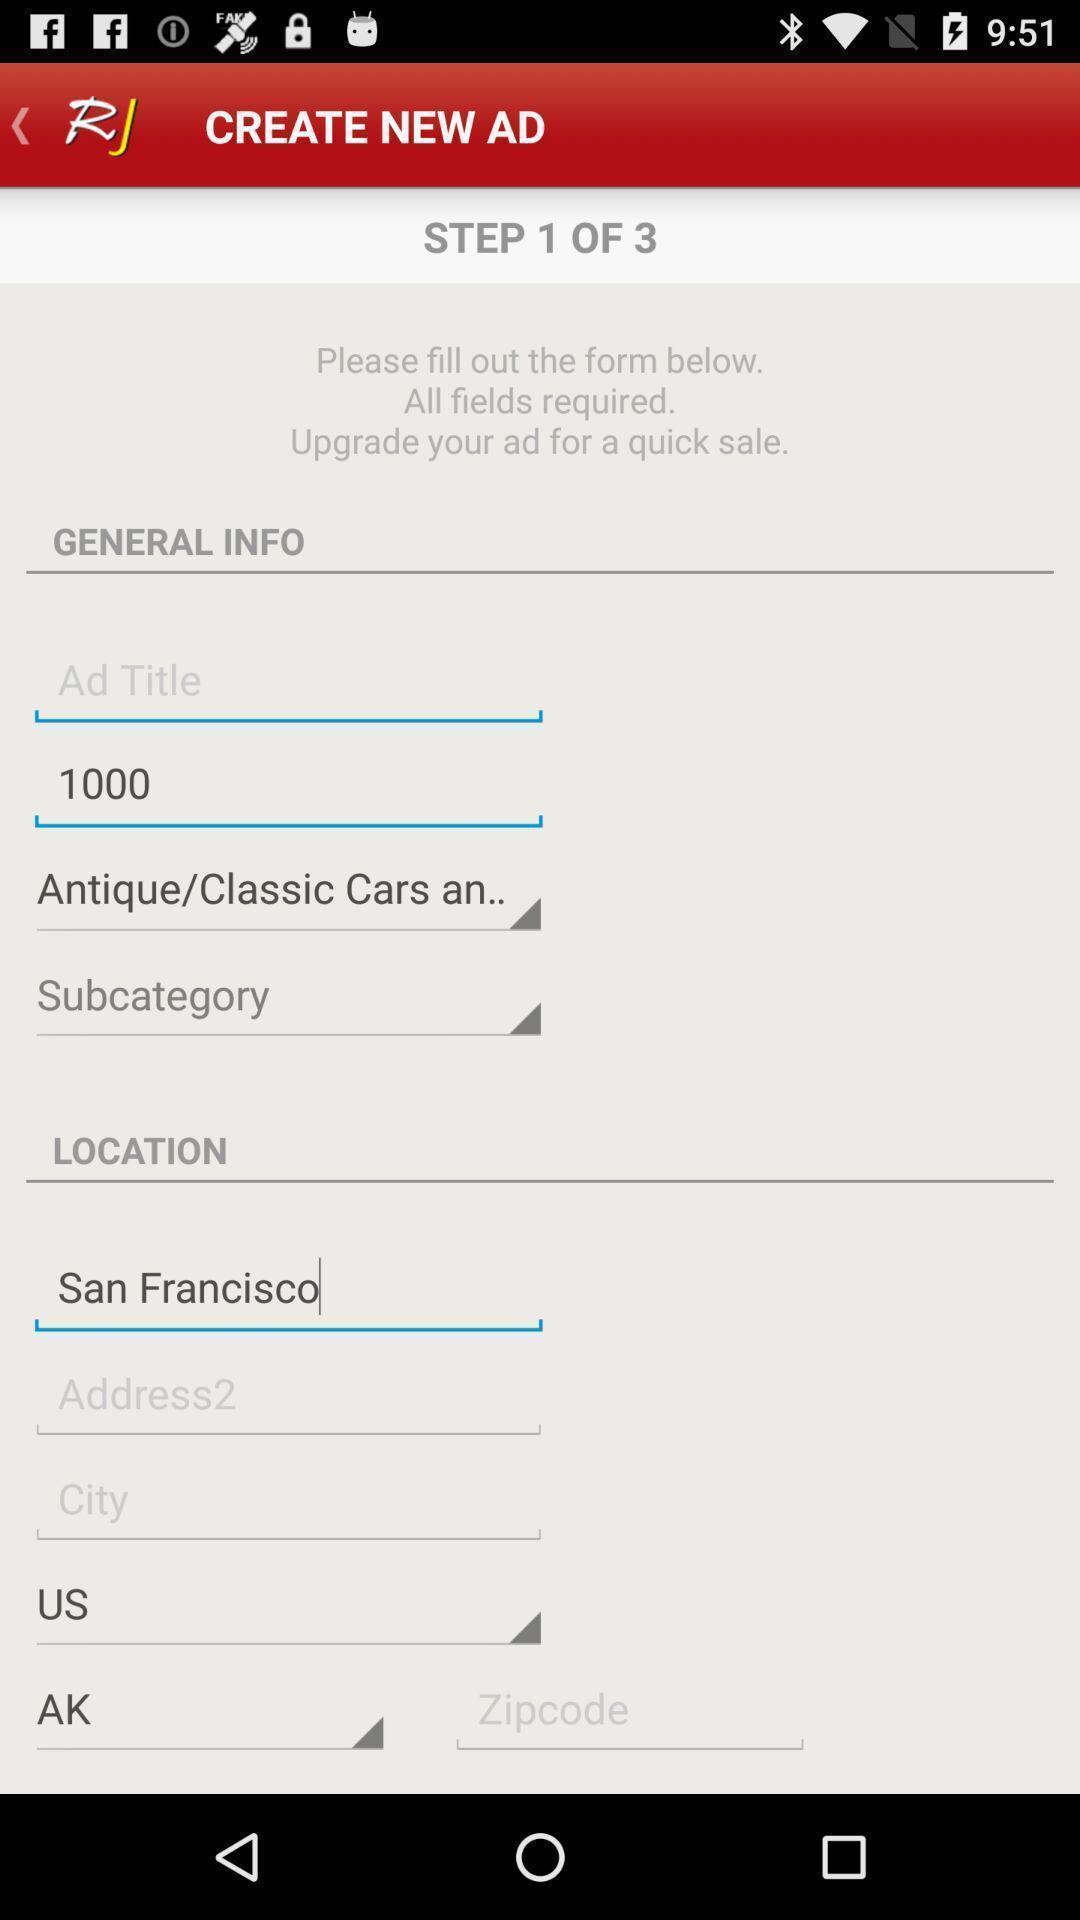Give me a narrative description of this picture. Screen displaying to create new ad. 